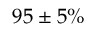<formula> <loc_0><loc_0><loc_500><loc_500>9 5 \pm 5 \%</formula> 